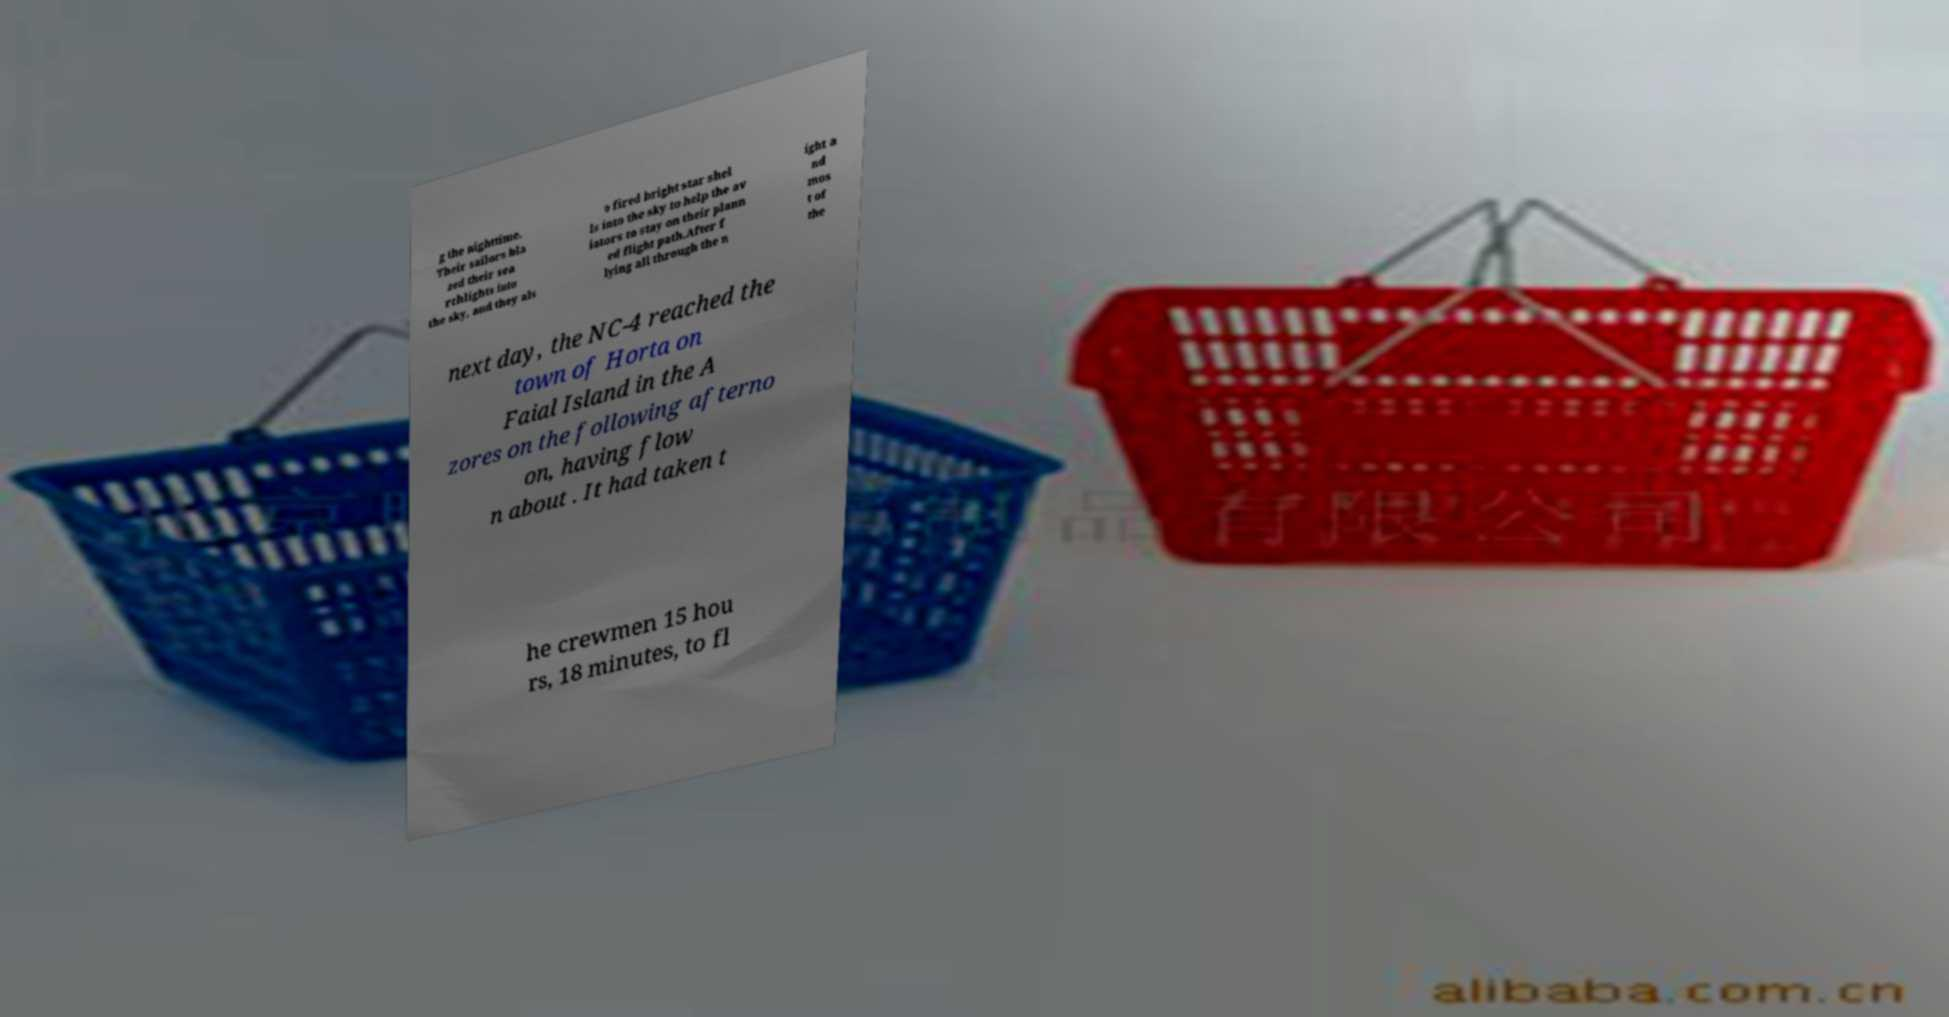For documentation purposes, I need the text within this image transcribed. Could you provide that? g the nighttime. Their sailors bla zed their sea rchlights into the sky, and they als o fired bright star shel ls into the sky to help the av iators to stay on their plann ed flight path.After f lying all through the n ight a nd mos t of the next day, the NC-4 reached the town of Horta on Faial Island in the A zores on the following afterno on, having flow n about . It had taken t he crewmen 15 hou rs, 18 minutes, to fl 